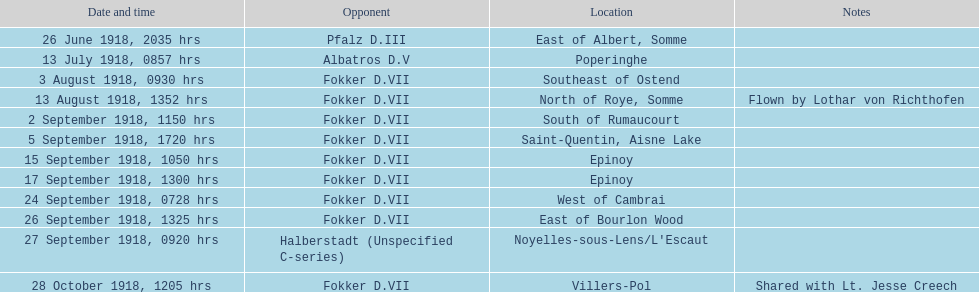I'm looking to parse the entire table for insights. Could you assist me with that? {'header': ['Date and time', 'Opponent', 'Location', 'Notes'], 'rows': [['26 June 1918, 2035 hrs', 'Pfalz D.III', 'East of Albert, Somme', ''], ['13 July 1918, 0857 hrs', 'Albatros D.V', 'Poperinghe', ''], ['3 August 1918, 0930 hrs', 'Fokker D.VII', 'Southeast of Ostend', ''], ['13 August 1918, 1352 hrs', 'Fokker D.VII', 'North of Roye, Somme', 'Flown by Lothar von Richthofen'], ['2 September 1918, 1150 hrs', 'Fokker D.VII', 'South of Rumaucourt', ''], ['5 September 1918, 1720 hrs', 'Fokker D.VII', 'Saint-Quentin, Aisne Lake', ''], ['15 September 1918, 1050 hrs', 'Fokker D.VII', 'Epinoy', ''], ['17 September 1918, 1300 hrs', 'Fokker D.VII', 'Epinoy', ''], ['24 September 1918, 0728 hrs', 'Fokker D.VII', 'West of Cambrai', ''], ['26 September 1918, 1325 hrs', 'Fokker D.VII', 'East of Bourlon Wood', ''], ['27 September 1918, 0920 hrs', 'Halberstadt (Unspecified C-series)', "Noyelles-sous-Lens/L'Escaut", ''], ['28 October 1918, 1205 hrs', 'Fokker D.VII', 'Villers-Pol', 'Shared with Lt. Jesse Creech']]} Which opponent did kindley have the most victories against? Fokker D.VII. 